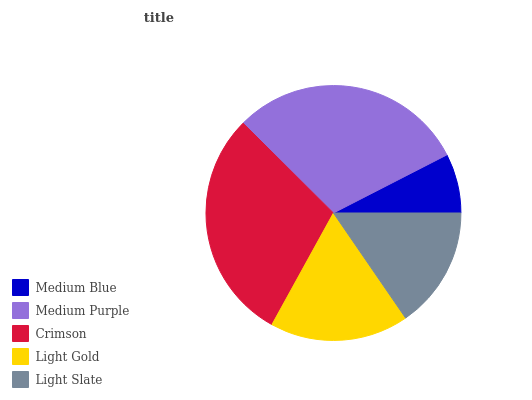Is Medium Blue the minimum?
Answer yes or no. Yes. Is Medium Purple the maximum?
Answer yes or no. Yes. Is Crimson the minimum?
Answer yes or no. No. Is Crimson the maximum?
Answer yes or no. No. Is Medium Purple greater than Crimson?
Answer yes or no. Yes. Is Crimson less than Medium Purple?
Answer yes or no. Yes. Is Crimson greater than Medium Purple?
Answer yes or no. No. Is Medium Purple less than Crimson?
Answer yes or no. No. Is Light Gold the high median?
Answer yes or no. Yes. Is Light Gold the low median?
Answer yes or no. Yes. Is Crimson the high median?
Answer yes or no. No. Is Medium Blue the low median?
Answer yes or no. No. 